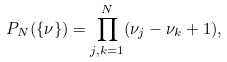Convert formula to latex. <formula><loc_0><loc_0><loc_500><loc_500>P _ { N } ( \{ \nu \} ) = \prod _ { j , k = 1 } ^ { N } ( \nu _ { j } - \nu _ { k } + 1 ) ,</formula> 